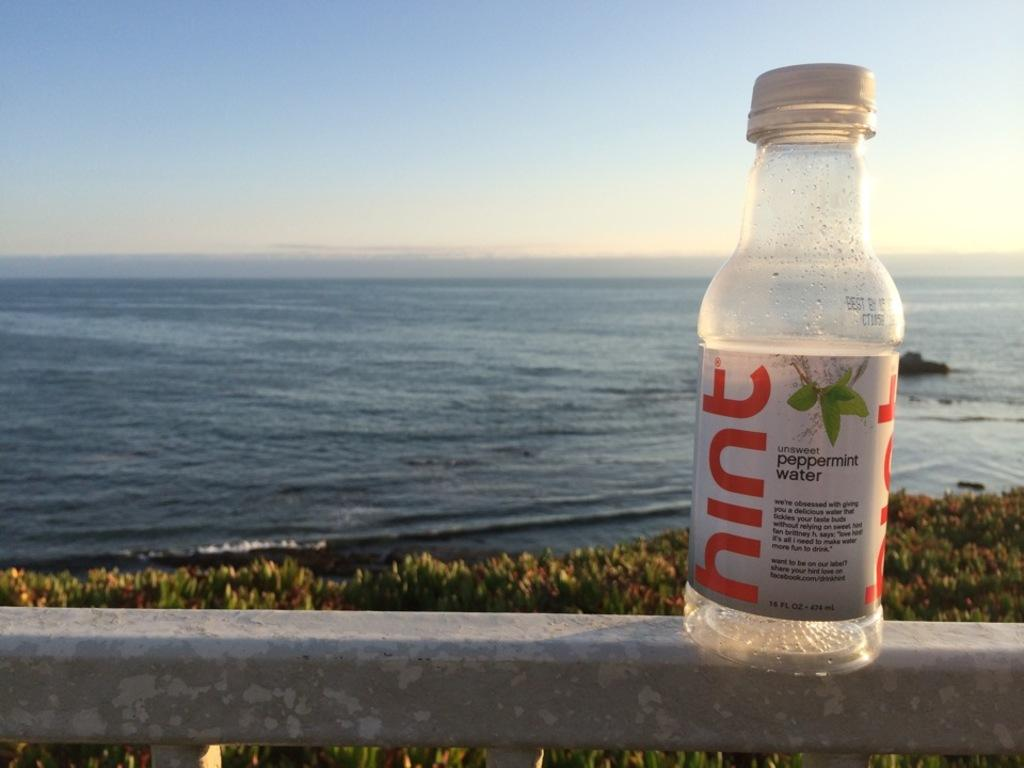<image>
Give a short and clear explanation of the subsequent image. Empty bottle of mint peppermint water on a seaside location. 